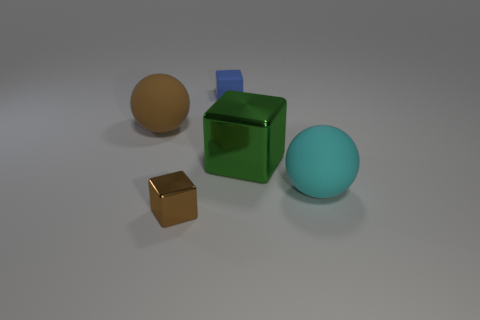What number of objects are big cubes or tiny blue objects that are on the right side of the tiny shiny cube?
Provide a short and direct response. 2. There is a matte ball that is to the left of the cyan rubber thing; does it have the same color as the rubber cube?
Ensure brevity in your answer.  No. Are there more small blocks that are in front of the tiny shiny thing than cyan things behind the green cube?
Offer a terse response. No. Are there any other things that have the same color as the big shiny cube?
Keep it short and to the point. No. How many things are either green blocks or matte spheres?
Ensure brevity in your answer.  3. There is a ball behind the cyan rubber sphere; is its size the same as the tiny blue rubber thing?
Keep it short and to the point. No. What number of other objects are the same size as the brown metallic block?
Your response must be concise. 1. Are there any brown spheres?
Provide a succinct answer. Yes. There is a matte sphere that is behind the matte sphere on the right side of the green metallic object; what is its size?
Your answer should be compact. Large. Does the matte ball that is behind the big cyan thing have the same color as the metallic object that is in front of the large cyan matte object?
Offer a very short reply. Yes. 